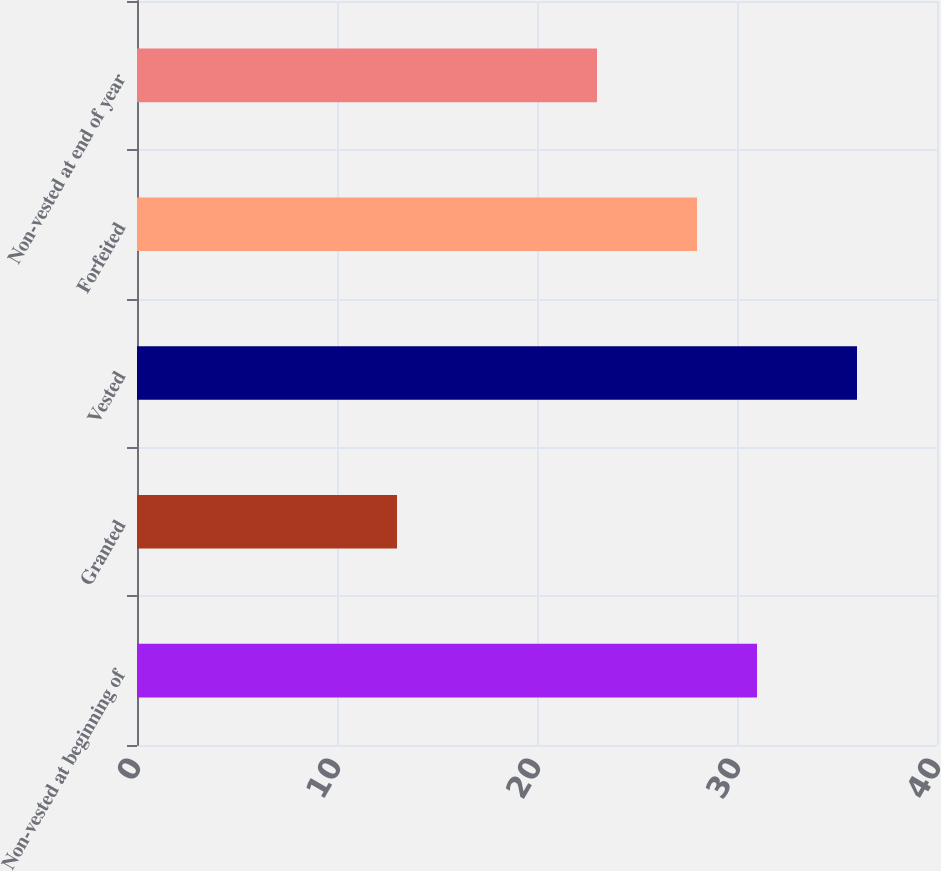<chart> <loc_0><loc_0><loc_500><loc_500><bar_chart><fcel>Non-vested at beginning of<fcel>Granted<fcel>Vested<fcel>Forfeited<fcel>Non-vested at end of year<nl><fcel>31<fcel>13<fcel>36<fcel>28<fcel>23<nl></chart> 